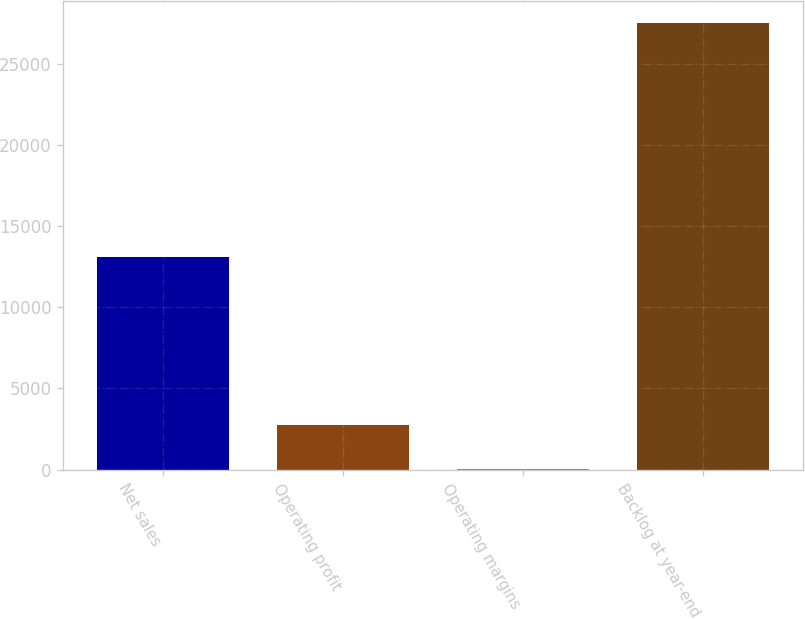Convert chart to OTSL. <chart><loc_0><loc_0><loc_500><loc_500><bar_chart><fcel>Net sales<fcel>Operating profit<fcel>Operating margins<fcel>Backlog at year-end<nl><fcel>13109<fcel>2760.26<fcel>11.4<fcel>27500<nl></chart> 